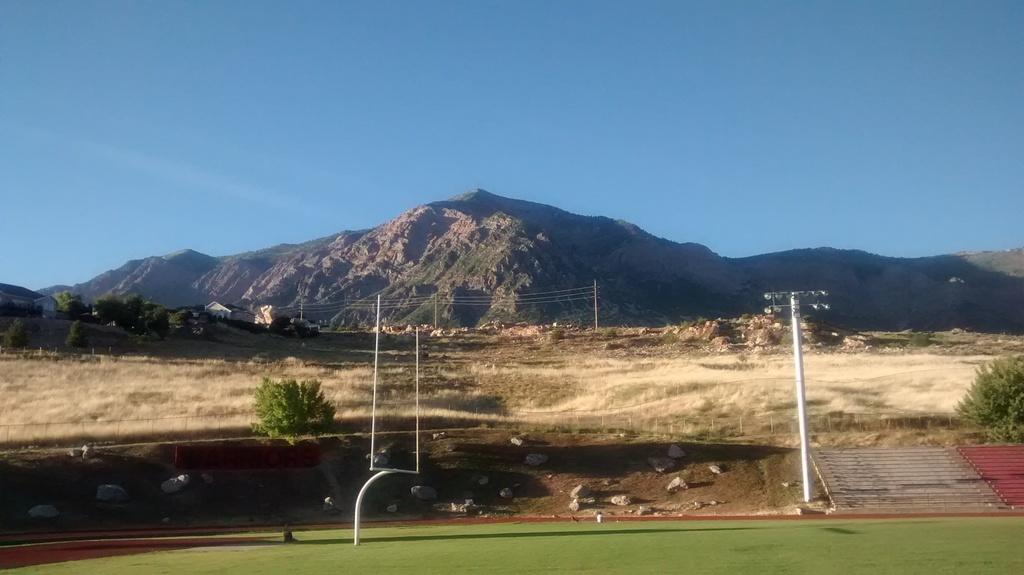What type of terrain is visible in the image? There is a hill in the image. What type of structures can be seen on the hill? There are houses in the image. What type of vegetation is present in the image? There are trees in the image. What covers the ground in the image? There is grass on the ground in the image. What type of lighting is present in the image? There are pole lights in the image. What color is the sky in the image? The sky is blue in the image. What type of care is being provided to the flesh in the image? There is no flesh or care being provided in the image; it features a hill, houses, trees, grass, pole lights, and a blue sky. 